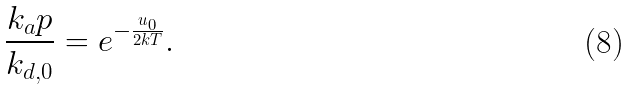<formula> <loc_0><loc_0><loc_500><loc_500>\frac { k _ { a } p } { k _ { d , 0 } } = e ^ { - \frac { u _ { 0 } } { 2 k T } } .</formula> 